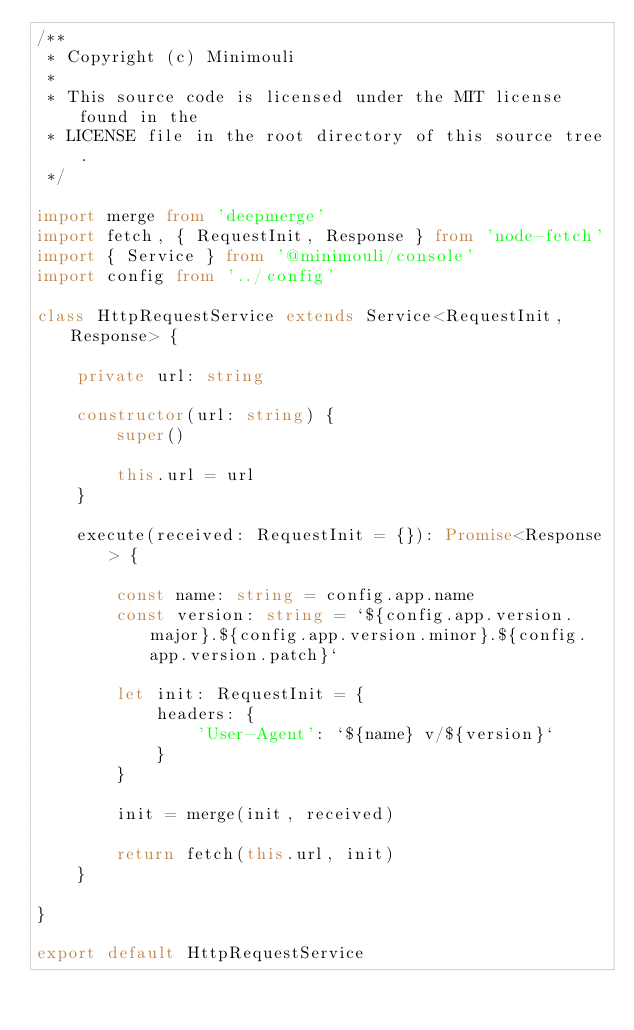Convert code to text. <code><loc_0><loc_0><loc_500><loc_500><_TypeScript_>/**
 * Copyright (c) Minimouli
 *
 * This source code is licensed under the MIT license found in the
 * LICENSE file in the root directory of this source tree.
 */

import merge from 'deepmerge'
import fetch, { RequestInit, Response } from 'node-fetch'
import { Service } from '@minimouli/console'
import config from '../config'

class HttpRequestService extends Service<RequestInit, Response> {

    private url: string

    constructor(url: string) {
        super()

        this.url = url
    }

    execute(received: RequestInit = {}): Promise<Response> {

        const name: string = config.app.name
        const version: string = `${config.app.version.major}.${config.app.version.minor}.${config.app.version.patch}`

        let init: RequestInit = {
            headers: {
                'User-Agent': `${name} v/${version}`
            }
        }

        init = merge(init, received)

        return fetch(this.url, init)
    }

}

export default HttpRequestService
</code> 